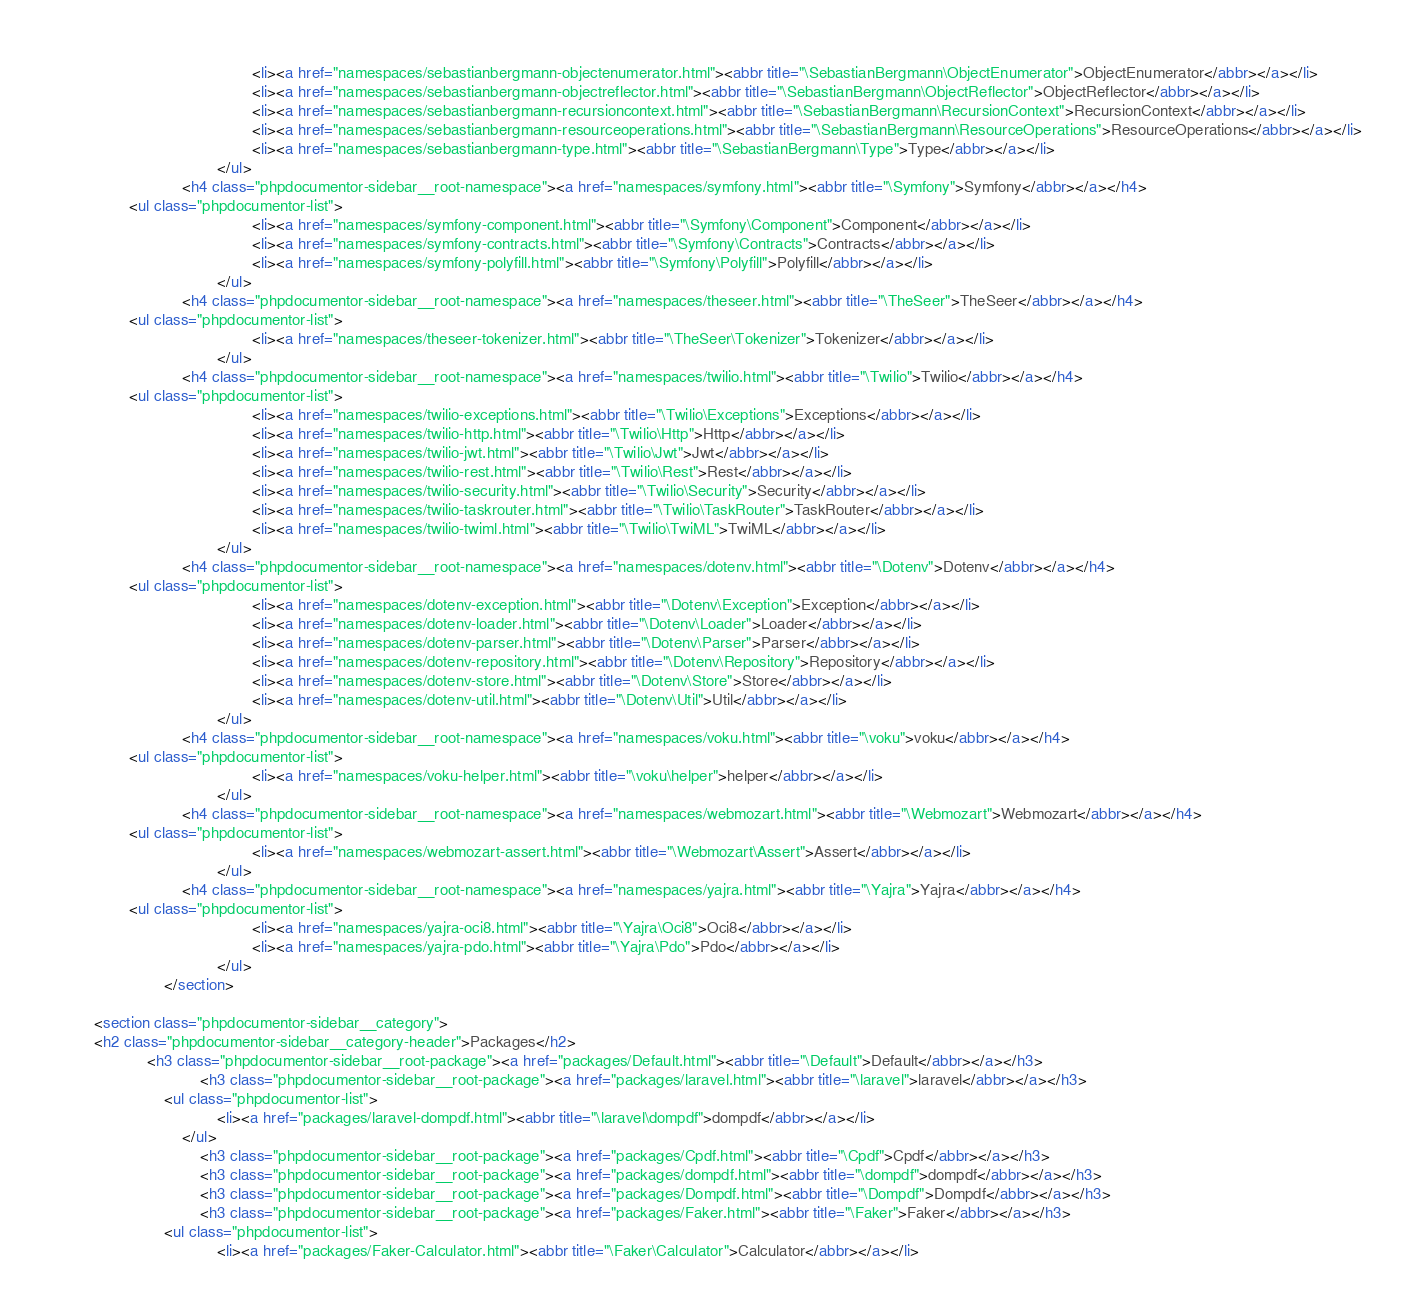<code> <loc_0><loc_0><loc_500><loc_500><_HTML_>                                            <li><a href="namespaces/sebastianbergmann-objectenumerator.html"><abbr title="\SebastianBergmann\ObjectEnumerator">ObjectEnumerator</abbr></a></li>
                                            <li><a href="namespaces/sebastianbergmann-objectreflector.html"><abbr title="\SebastianBergmann\ObjectReflector">ObjectReflector</abbr></a></li>
                                            <li><a href="namespaces/sebastianbergmann-recursioncontext.html"><abbr title="\SebastianBergmann\RecursionContext">RecursionContext</abbr></a></li>
                                            <li><a href="namespaces/sebastianbergmann-resourceoperations.html"><abbr title="\SebastianBergmann\ResourceOperations">ResourceOperations</abbr></a></li>
                                            <li><a href="namespaces/sebastianbergmann-type.html"><abbr title="\SebastianBergmann\Type">Type</abbr></a></li>
                                    </ul>
                            <h4 class="phpdocumentor-sidebar__root-namespace"><a href="namespaces/symfony.html"><abbr title="\Symfony">Symfony</abbr></a></h4>
                <ul class="phpdocumentor-list">
                                            <li><a href="namespaces/symfony-component.html"><abbr title="\Symfony\Component">Component</abbr></a></li>
                                            <li><a href="namespaces/symfony-contracts.html"><abbr title="\Symfony\Contracts">Contracts</abbr></a></li>
                                            <li><a href="namespaces/symfony-polyfill.html"><abbr title="\Symfony\Polyfill">Polyfill</abbr></a></li>
                                    </ul>
                            <h4 class="phpdocumentor-sidebar__root-namespace"><a href="namespaces/theseer.html"><abbr title="\TheSeer">TheSeer</abbr></a></h4>
                <ul class="phpdocumentor-list">
                                            <li><a href="namespaces/theseer-tokenizer.html"><abbr title="\TheSeer\Tokenizer">Tokenizer</abbr></a></li>
                                    </ul>
                            <h4 class="phpdocumentor-sidebar__root-namespace"><a href="namespaces/twilio.html"><abbr title="\Twilio">Twilio</abbr></a></h4>
                <ul class="phpdocumentor-list">
                                            <li><a href="namespaces/twilio-exceptions.html"><abbr title="\Twilio\Exceptions">Exceptions</abbr></a></li>
                                            <li><a href="namespaces/twilio-http.html"><abbr title="\Twilio\Http">Http</abbr></a></li>
                                            <li><a href="namespaces/twilio-jwt.html"><abbr title="\Twilio\Jwt">Jwt</abbr></a></li>
                                            <li><a href="namespaces/twilio-rest.html"><abbr title="\Twilio\Rest">Rest</abbr></a></li>
                                            <li><a href="namespaces/twilio-security.html"><abbr title="\Twilio\Security">Security</abbr></a></li>
                                            <li><a href="namespaces/twilio-taskrouter.html"><abbr title="\Twilio\TaskRouter">TaskRouter</abbr></a></li>
                                            <li><a href="namespaces/twilio-twiml.html"><abbr title="\Twilio\TwiML">TwiML</abbr></a></li>
                                    </ul>
                            <h4 class="phpdocumentor-sidebar__root-namespace"><a href="namespaces/dotenv.html"><abbr title="\Dotenv">Dotenv</abbr></a></h4>
                <ul class="phpdocumentor-list">
                                            <li><a href="namespaces/dotenv-exception.html"><abbr title="\Dotenv\Exception">Exception</abbr></a></li>
                                            <li><a href="namespaces/dotenv-loader.html"><abbr title="\Dotenv\Loader">Loader</abbr></a></li>
                                            <li><a href="namespaces/dotenv-parser.html"><abbr title="\Dotenv\Parser">Parser</abbr></a></li>
                                            <li><a href="namespaces/dotenv-repository.html"><abbr title="\Dotenv\Repository">Repository</abbr></a></li>
                                            <li><a href="namespaces/dotenv-store.html"><abbr title="\Dotenv\Store">Store</abbr></a></li>
                                            <li><a href="namespaces/dotenv-util.html"><abbr title="\Dotenv\Util">Util</abbr></a></li>
                                    </ul>
                            <h4 class="phpdocumentor-sidebar__root-namespace"><a href="namespaces/voku.html"><abbr title="\voku">voku</abbr></a></h4>
                <ul class="phpdocumentor-list">
                                            <li><a href="namespaces/voku-helper.html"><abbr title="\voku\helper">helper</abbr></a></li>
                                    </ul>
                            <h4 class="phpdocumentor-sidebar__root-namespace"><a href="namespaces/webmozart.html"><abbr title="\Webmozart">Webmozart</abbr></a></h4>
                <ul class="phpdocumentor-list">
                                            <li><a href="namespaces/webmozart-assert.html"><abbr title="\Webmozart\Assert">Assert</abbr></a></li>
                                    </ul>
                            <h4 class="phpdocumentor-sidebar__root-namespace"><a href="namespaces/yajra.html"><abbr title="\Yajra">Yajra</abbr></a></h4>
                <ul class="phpdocumentor-list">
                                            <li><a href="namespaces/yajra-oci8.html"><abbr title="\Yajra\Oci8">Oci8</abbr></a></li>
                                            <li><a href="namespaces/yajra-pdo.html"><abbr title="\Yajra\Pdo">Pdo</abbr></a></li>
                                    </ul>
                        </section>

        <section class="phpdocumentor-sidebar__category">
        <h2 class="phpdocumentor-sidebar__category-header">Packages</h2>
                    <h3 class="phpdocumentor-sidebar__root-package"><a href="packages/Default.html"><abbr title="\Default">Default</abbr></a></h3>
                                <h3 class="phpdocumentor-sidebar__root-package"><a href="packages/laravel.html"><abbr title="\laravel">laravel</abbr></a></h3>
                        <ul class="phpdocumentor-list">
                                    <li><a href="packages/laravel-dompdf.html"><abbr title="\laravel\dompdf">dompdf</abbr></a></li>
                            </ul>
                                <h3 class="phpdocumentor-sidebar__root-package"><a href="packages/Cpdf.html"><abbr title="\Cpdf">Cpdf</abbr></a></h3>
                                <h3 class="phpdocumentor-sidebar__root-package"><a href="packages/dompdf.html"><abbr title="\dompdf">dompdf</abbr></a></h3>
                                <h3 class="phpdocumentor-sidebar__root-package"><a href="packages/Dompdf.html"><abbr title="\Dompdf">Dompdf</abbr></a></h3>
                                <h3 class="phpdocumentor-sidebar__root-package"><a href="packages/Faker.html"><abbr title="\Faker">Faker</abbr></a></h3>
                        <ul class="phpdocumentor-list">
                                    <li><a href="packages/Faker-Calculator.html"><abbr title="\Faker\Calculator">Calculator</abbr></a></li></code> 